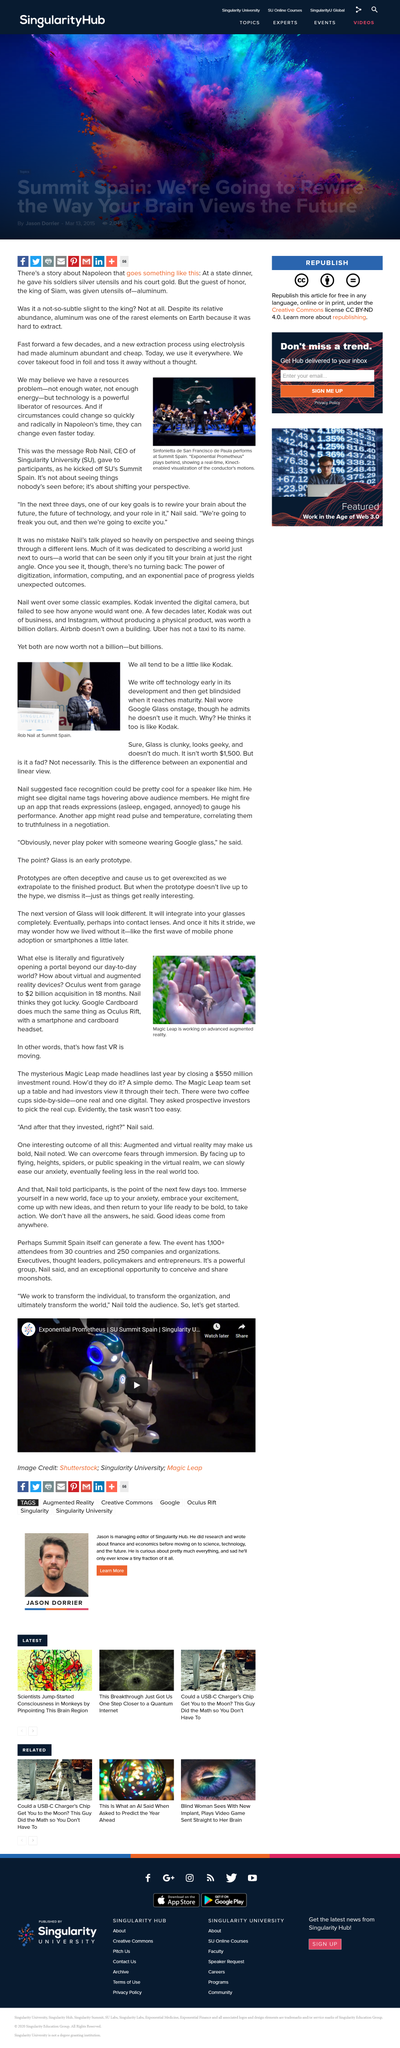Outline some significant characteristics in this image. Aluminum became abundant and affordable as a result of a new extraction process using electrolysis. The photograph displays Rob Nail, who is located in Summit Spain. In this article, who believes they got lucky? Nail it down. Rob Nail is the CEO of Singularity University. Oculus Go was acquired by a garage for a total of $2 billion. 